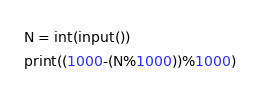Convert code to text. <code><loc_0><loc_0><loc_500><loc_500><_Python_>N = int(input())
print((1000-(N%1000))%1000)
</code> 